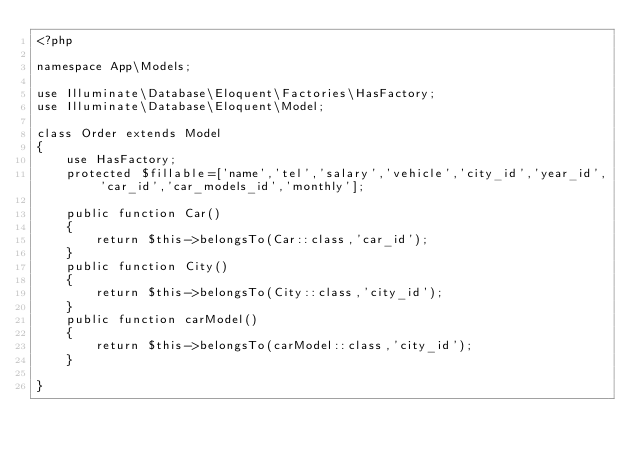Convert code to text. <code><loc_0><loc_0><loc_500><loc_500><_PHP_><?php

namespace App\Models;

use Illuminate\Database\Eloquent\Factories\HasFactory;
use Illuminate\Database\Eloquent\Model;

class Order extends Model
{
    use HasFactory;
    protected $fillable=['name','tel','salary','vehicle','city_id','year_id','car_id','car_models_id','monthly'];

    public function Car()
    {
        return $this->belongsTo(Car::class,'car_id');
    }
    public function City()
    {
        return $this->belongsTo(City::class,'city_id');
    }
    public function carModel()
    {
        return $this->belongsTo(carModel::class,'city_id');
    }

}
</code> 